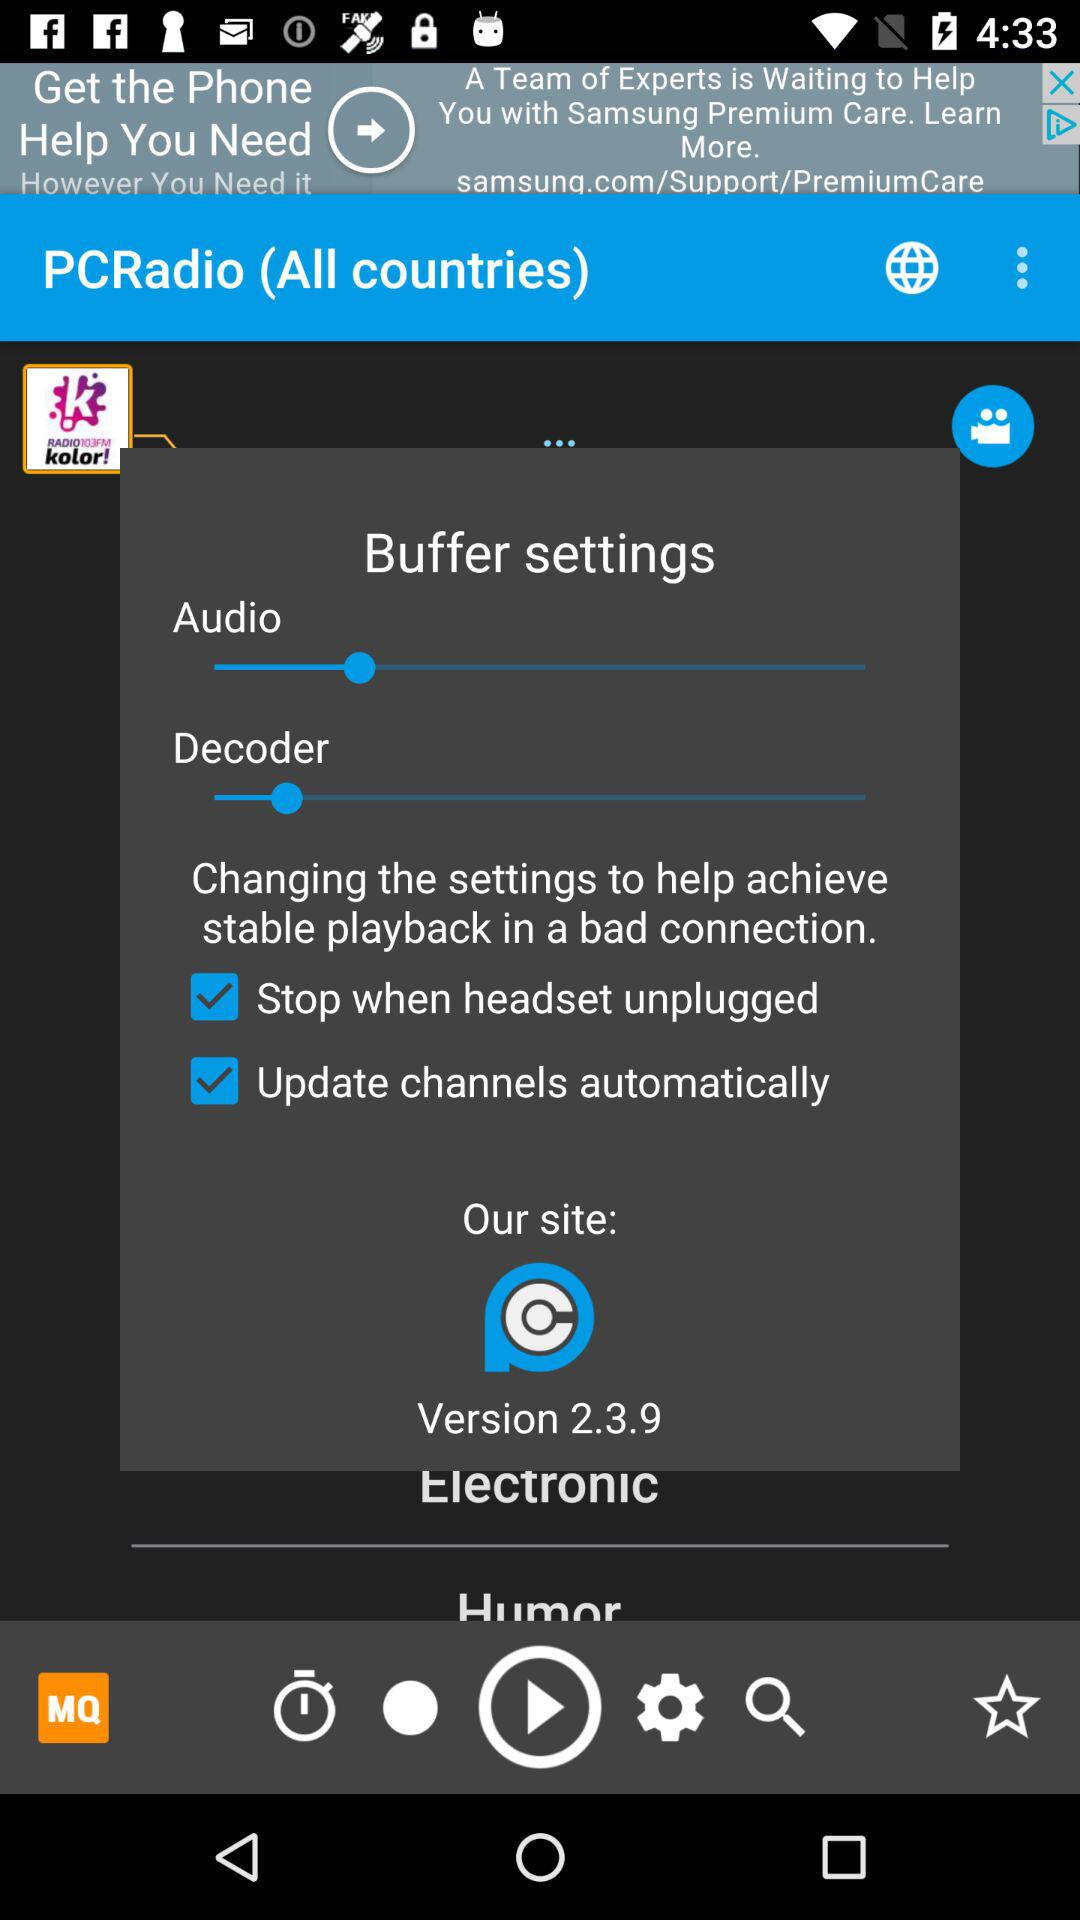What is the status of "Update channels automatically"? The status is "on". 